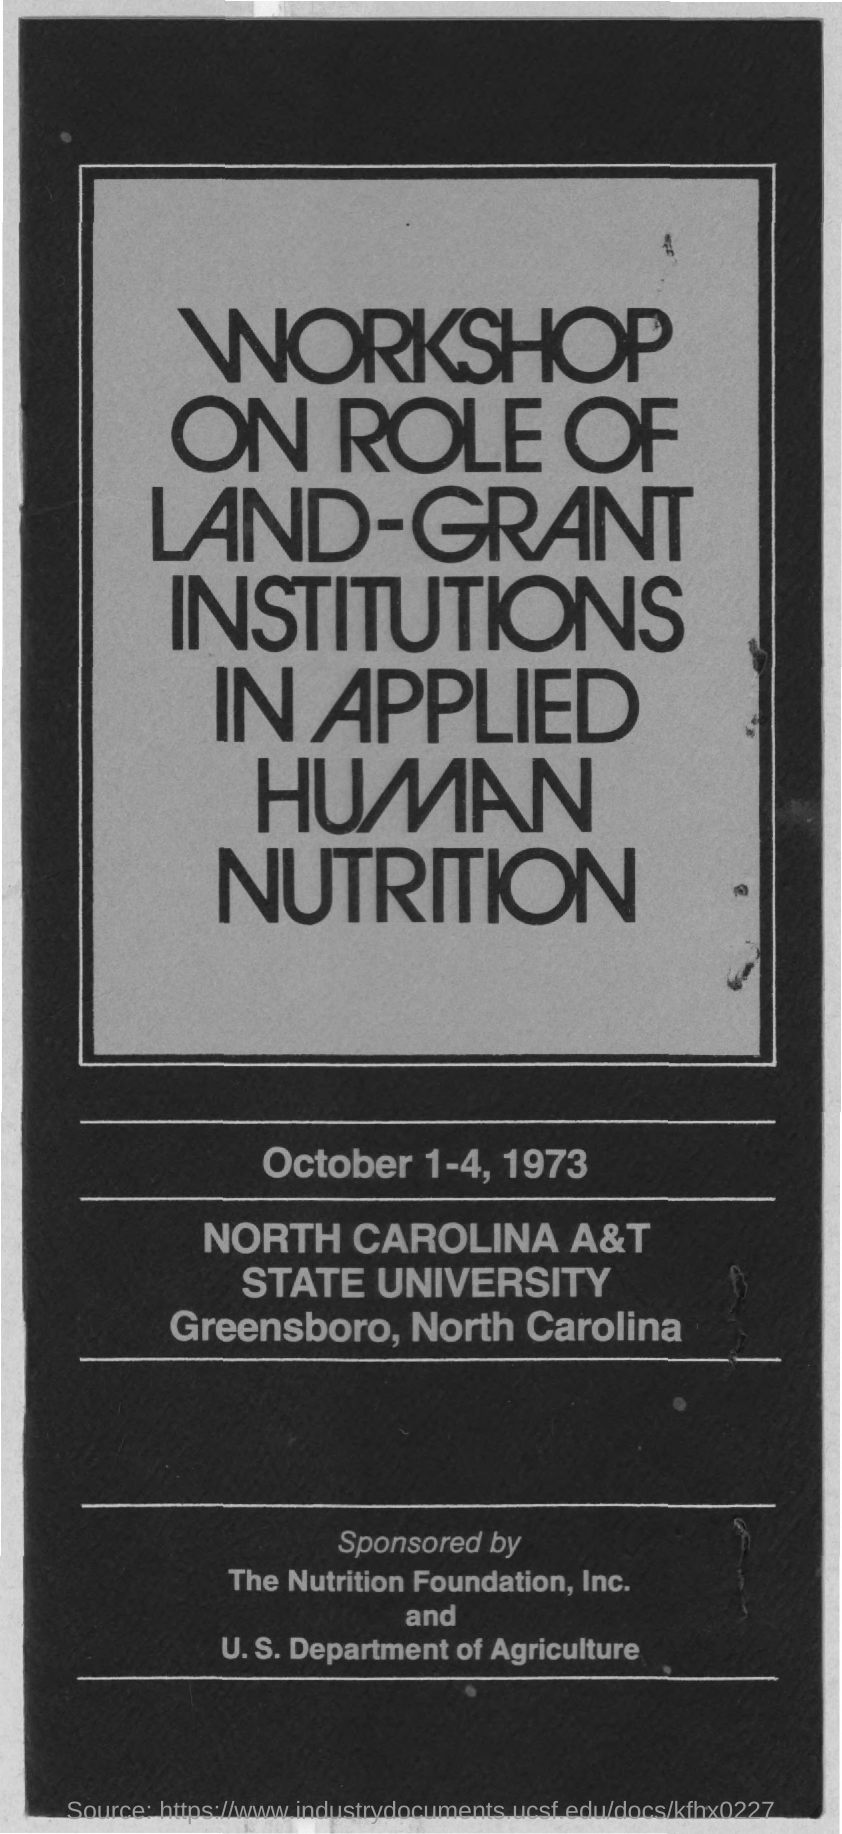On which dates this workshop was conducted ?
Keep it short and to the point. October  1-4 , 1973. 